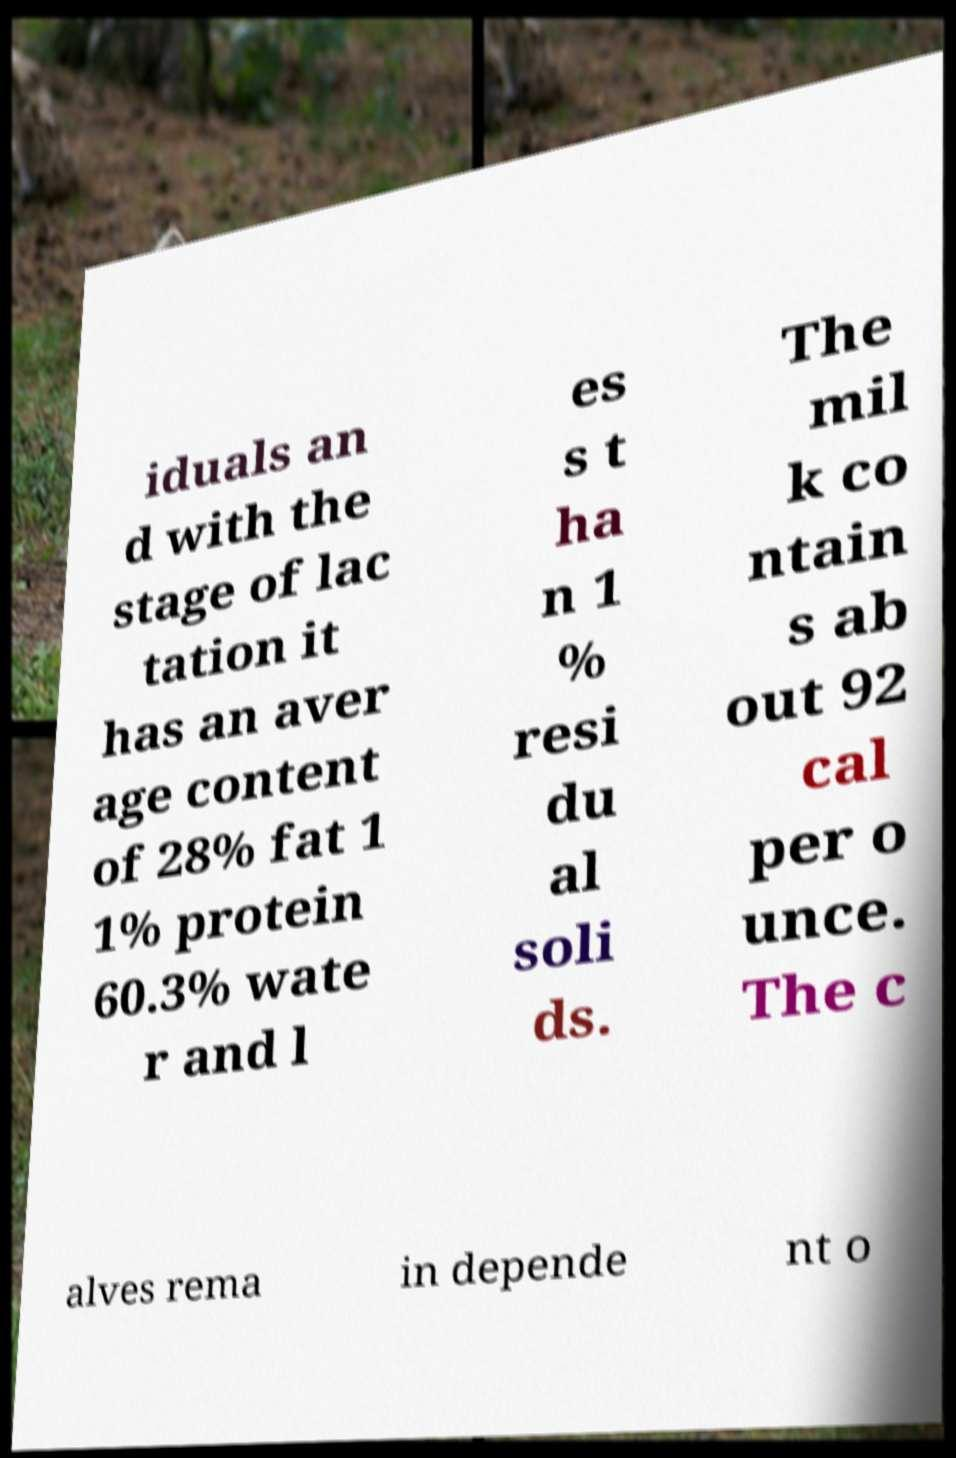Can you read and provide the text displayed in the image?This photo seems to have some interesting text. Can you extract and type it out for me? iduals an d with the stage of lac tation it has an aver age content of 28% fat 1 1% protein 60.3% wate r and l es s t ha n 1 % resi du al soli ds. The mil k co ntain s ab out 92 cal per o unce. The c alves rema in depende nt o 